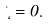<formula> <loc_0><loc_0><loc_500><loc_500>\Delta \Phi = 0 .</formula> 